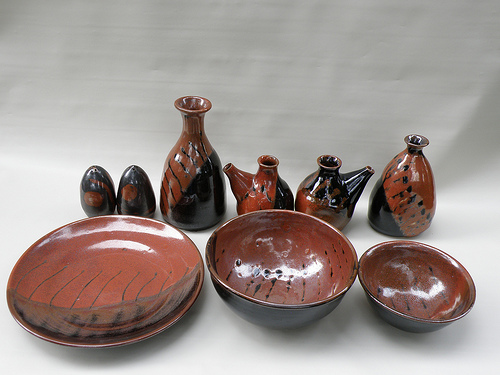Please provide the bounding box coordinate of the region this sentence describes: Large black and red pottery for holding liquid. The bounding box for the 'Large black and red pottery for holding liquid' is [0.31, 0.3, 0.45, 0.58]. This pottery piece is both functional and beautifully designed. 